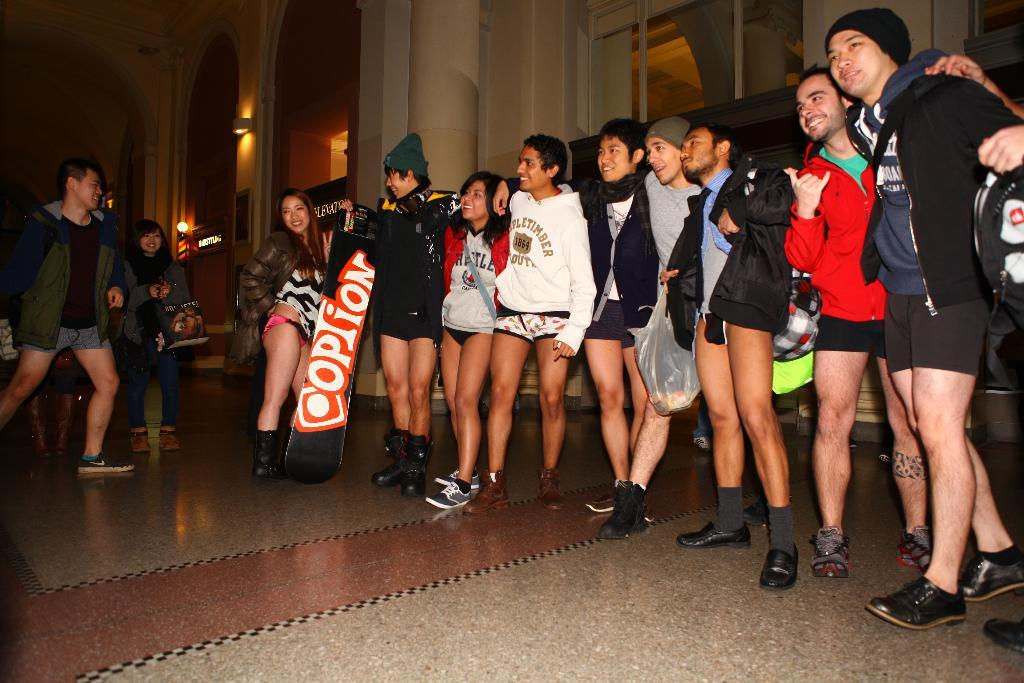<image>
Give a short and clear explanation of the subsequent image. A group of people all in shorts link arms and smile as a girl holds a banner with Coption written on it. 